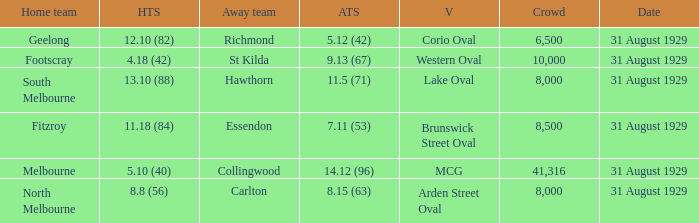What was the score of the home team when the away team scored 14.12 (96)? 5.10 (40). 